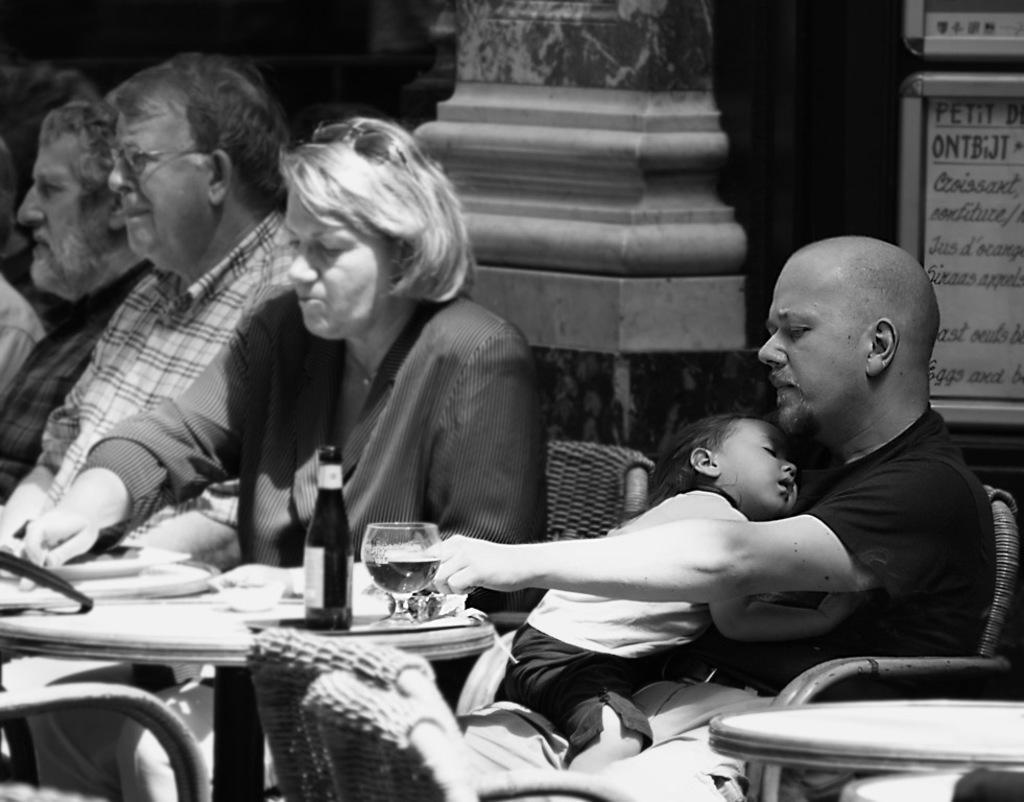How would you summarize this image in a sentence or two? In this picture there are few people sitting on the chair. There is a glass, bowl, bottle on the table. There is a man holding a child sitting on the chair. 